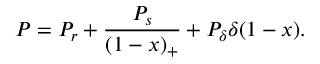<formula> <loc_0><loc_0><loc_500><loc_500>P = P _ { r } + \frac { P _ { s } } { ( 1 - x ) _ { + } } + P _ { \delta } \delta ( 1 - x ) .</formula> 